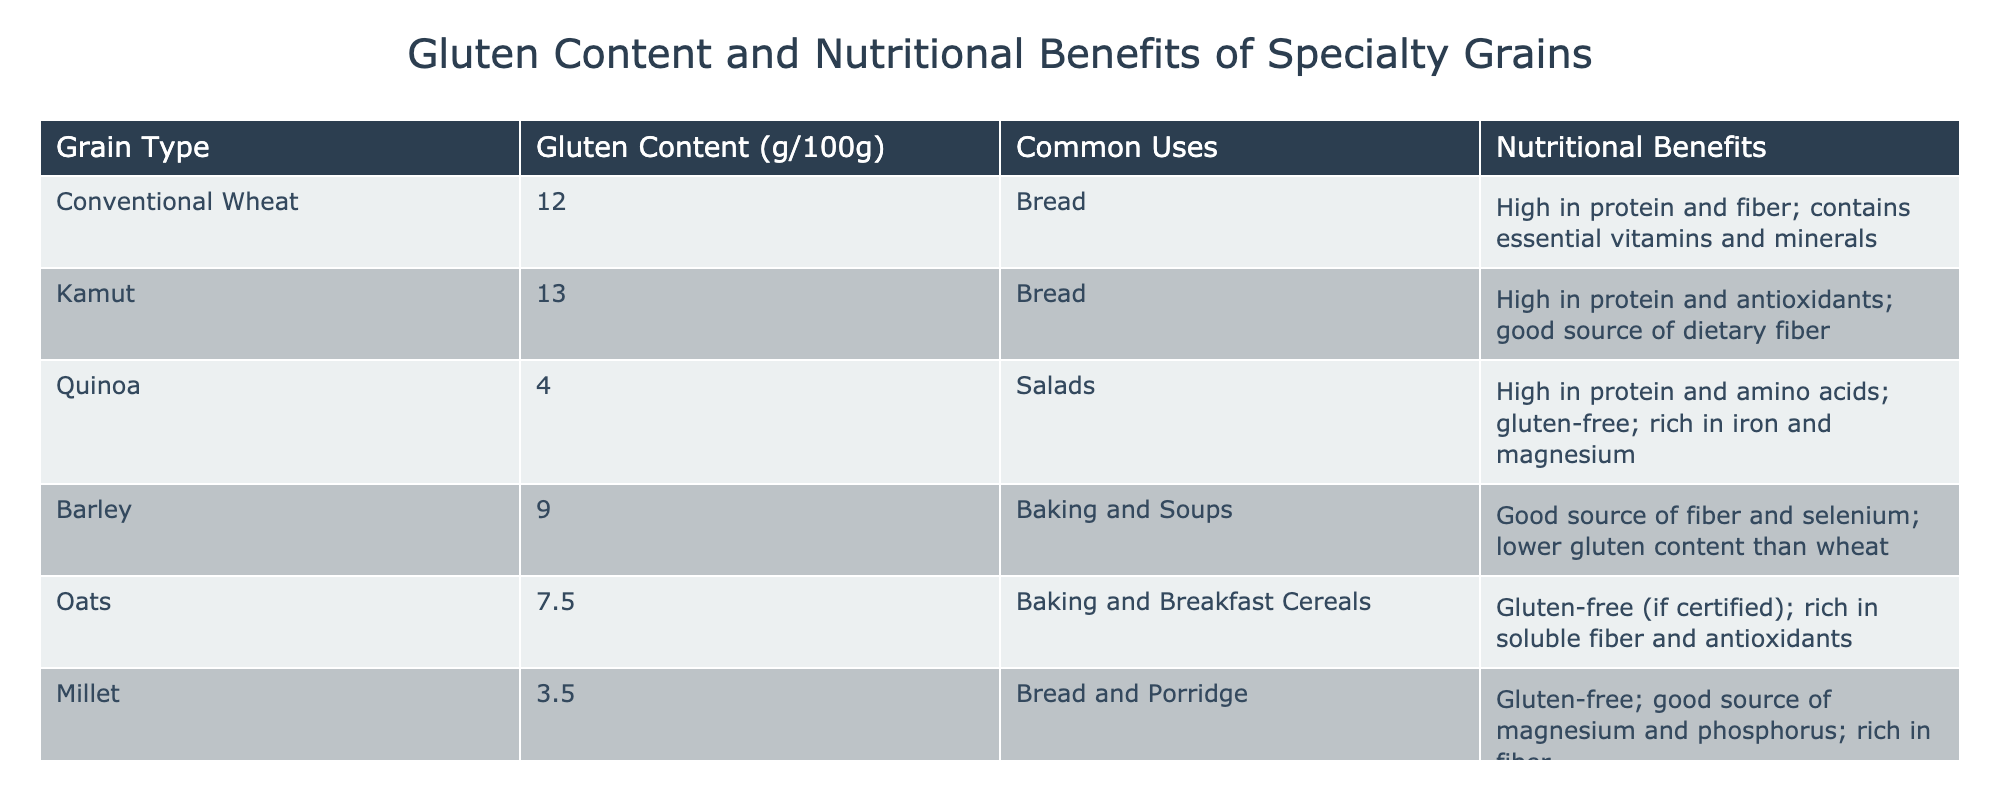What is the gluten content of Kamut? The table lists Kamut under the "Grain Type" column with its corresponding gluten content provided in the "Gluten Content (g/100g)" column. According to the table, Kamut has a gluten content of 13.0 grams per 100 grams.
Answer: 13.0 Which grain has the lowest gluten content? To find the lowest gluten content, we need to compare the values in the "Gluten Content (g/100g)" column. The values are 12.0 (Conventional Wheat), 13.0 (Kamut), 4.0 (Quinoa), 9.0 (Barley), 7.5 (Oats), and 3.5 (Millet). The lowest value is 3.5, corresponding to Millet.
Answer: Millet True or False: Oats have a higher gluten content than Barley. To answer this question, we refer to the "Gluten Content (g/100g)" values for Oats (7.5) and Barley (9.0). Since 7.5 is less than 9.0, it is false that Oats have a higher gluten content than Barley.
Answer: False What is the average gluten content of all the grains listed in the table? First, we total the gluten content values: 12.0 (Wheat) + 13.0 (Kamut) + 4.0 (Quinoa) + 9.0 (Barley) + 7.5 (Oats) + 3.5 (Millet) = 49.0 grams. With 6 grains, the average is calculated as 49.0 / 6 = approximately 8.17 grams per 100 grams.
Answer: 8.17 Which specialty grain has the highest nutritional benefit related to antioxidants? We look for grains noted for being high in antioxidants in the "Nutritional Benefits" section. Kamut specifically mentions it is high in antioxidants. The other entries do not highlight this benefit. Therefore, Kamut stands out as having the highest antioxidant benefit.
Answer: Kamut 